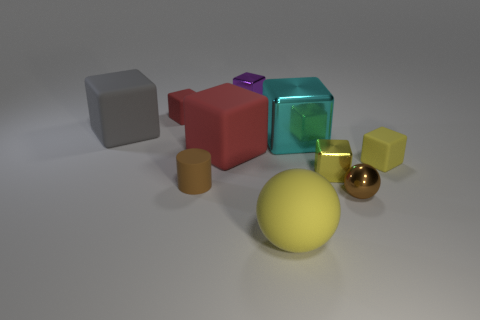There is a small red object that is the same shape as the large cyan shiny object; what is its material?
Offer a terse response. Rubber. Are there any other things that have the same material as the brown cylinder?
Keep it short and to the point. Yes. Is the color of the big shiny cube the same as the cylinder?
Make the answer very short. No. There is a brown object left of the yellow cube left of the tiny brown metal ball; what is its shape?
Your answer should be very brief. Cylinder. There is a cyan object that is made of the same material as the tiny purple object; what is its shape?
Give a very brief answer. Cube. What number of other objects are the same shape as the cyan metal object?
Offer a very short reply. 6. Do the shiny thing that is behind the cyan shiny block and the big cyan cube have the same size?
Make the answer very short. No. Are there more large yellow matte objects that are behind the brown rubber cylinder than large blue shiny cylinders?
Ensure brevity in your answer.  No. How many yellow objects are in front of the small rubber block behind the big red matte block?
Keep it short and to the point. 3. Is the number of purple things that are behind the tiny sphere less than the number of small purple balls?
Offer a terse response. No. 